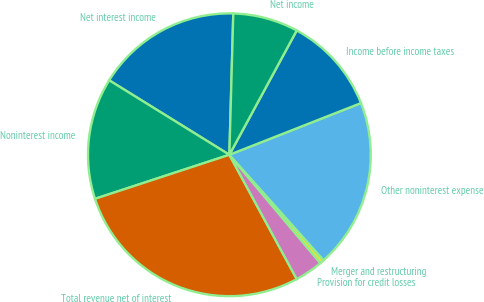Convert chart to OTSL. <chart><loc_0><loc_0><loc_500><loc_500><pie_chart><fcel>Net interest income<fcel>Noninterest income<fcel>Total revenue net of interest<fcel>Provision for credit losses<fcel>Merger and restructuring<fcel>Other noninterest expense<fcel>Income before income taxes<fcel>Net income<nl><fcel>16.61%<fcel>13.87%<fcel>27.86%<fcel>3.22%<fcel>0.48%<fcel>19.35%<fcel>11.14%<fcel>7.46%<nl></chart> 